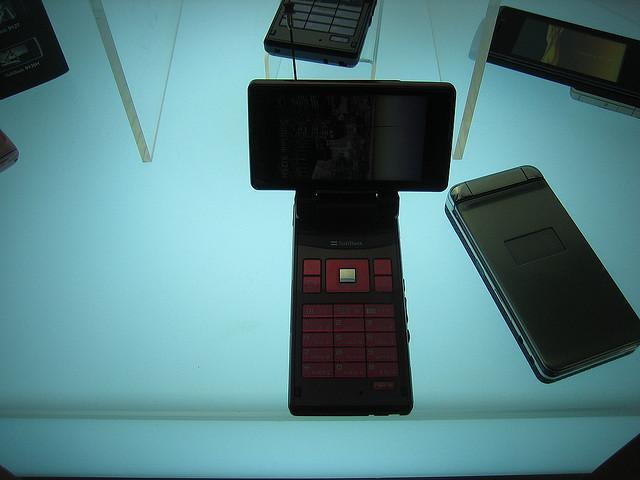How many cell phones can be seen?
Give a very brief answer. 4. How many pairs of scissors are pictured?
Give a very brief answer. 0. 